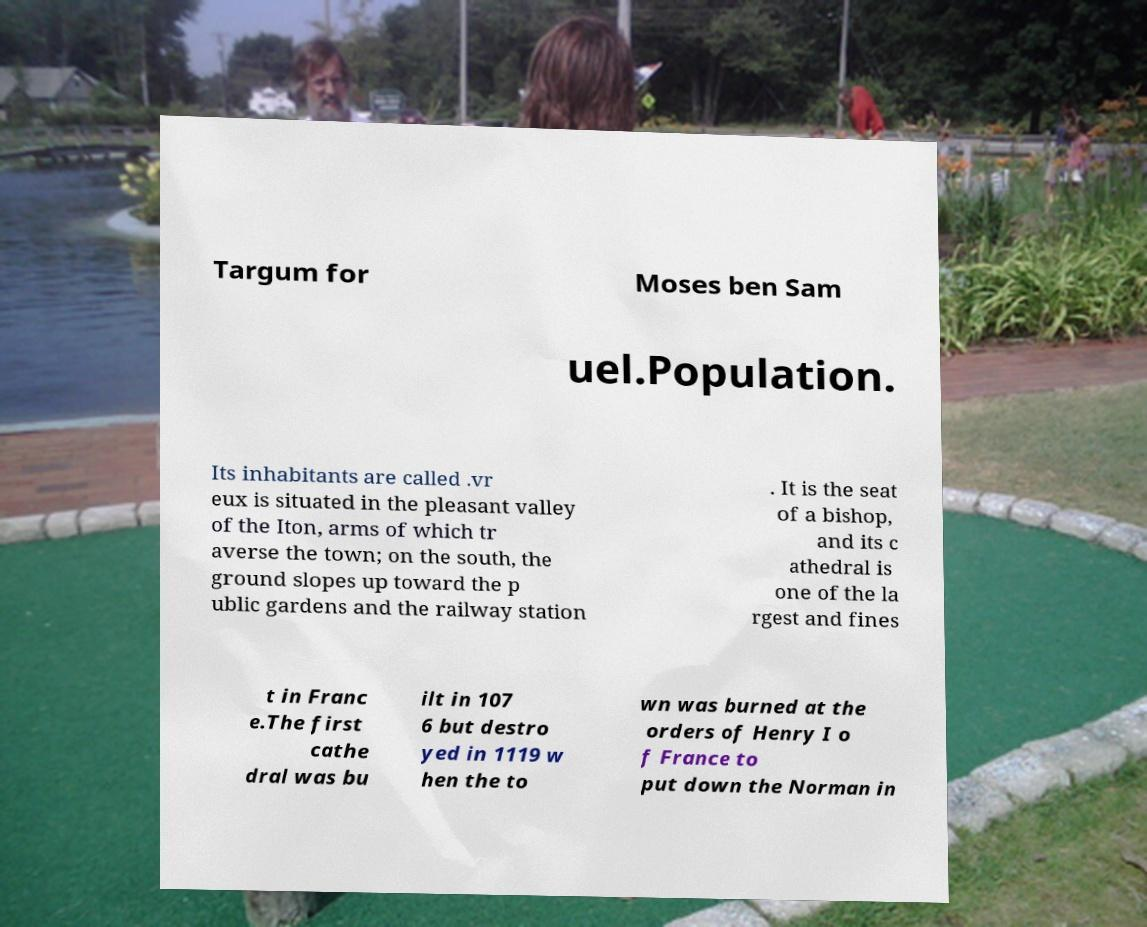Can you accurately transcribe the text from the provided image for me? Targum for Moses ben Sam uel.Population. Its inhabitants are called .vr eux is situated in the pleasant valley of the Iton, arms of which tr averse the town; on the south, the ground slopes up toward the p ublic gardens and the railway station . It is the seat of a bishop, and its c athedral is one of the la rgest and fines t in Franc e.The first cathe dral was bu ilt in 107 6 but destro yed in 1119 w hen the to wn was burned at the orders of Henry I o f France to put down the Norman in 